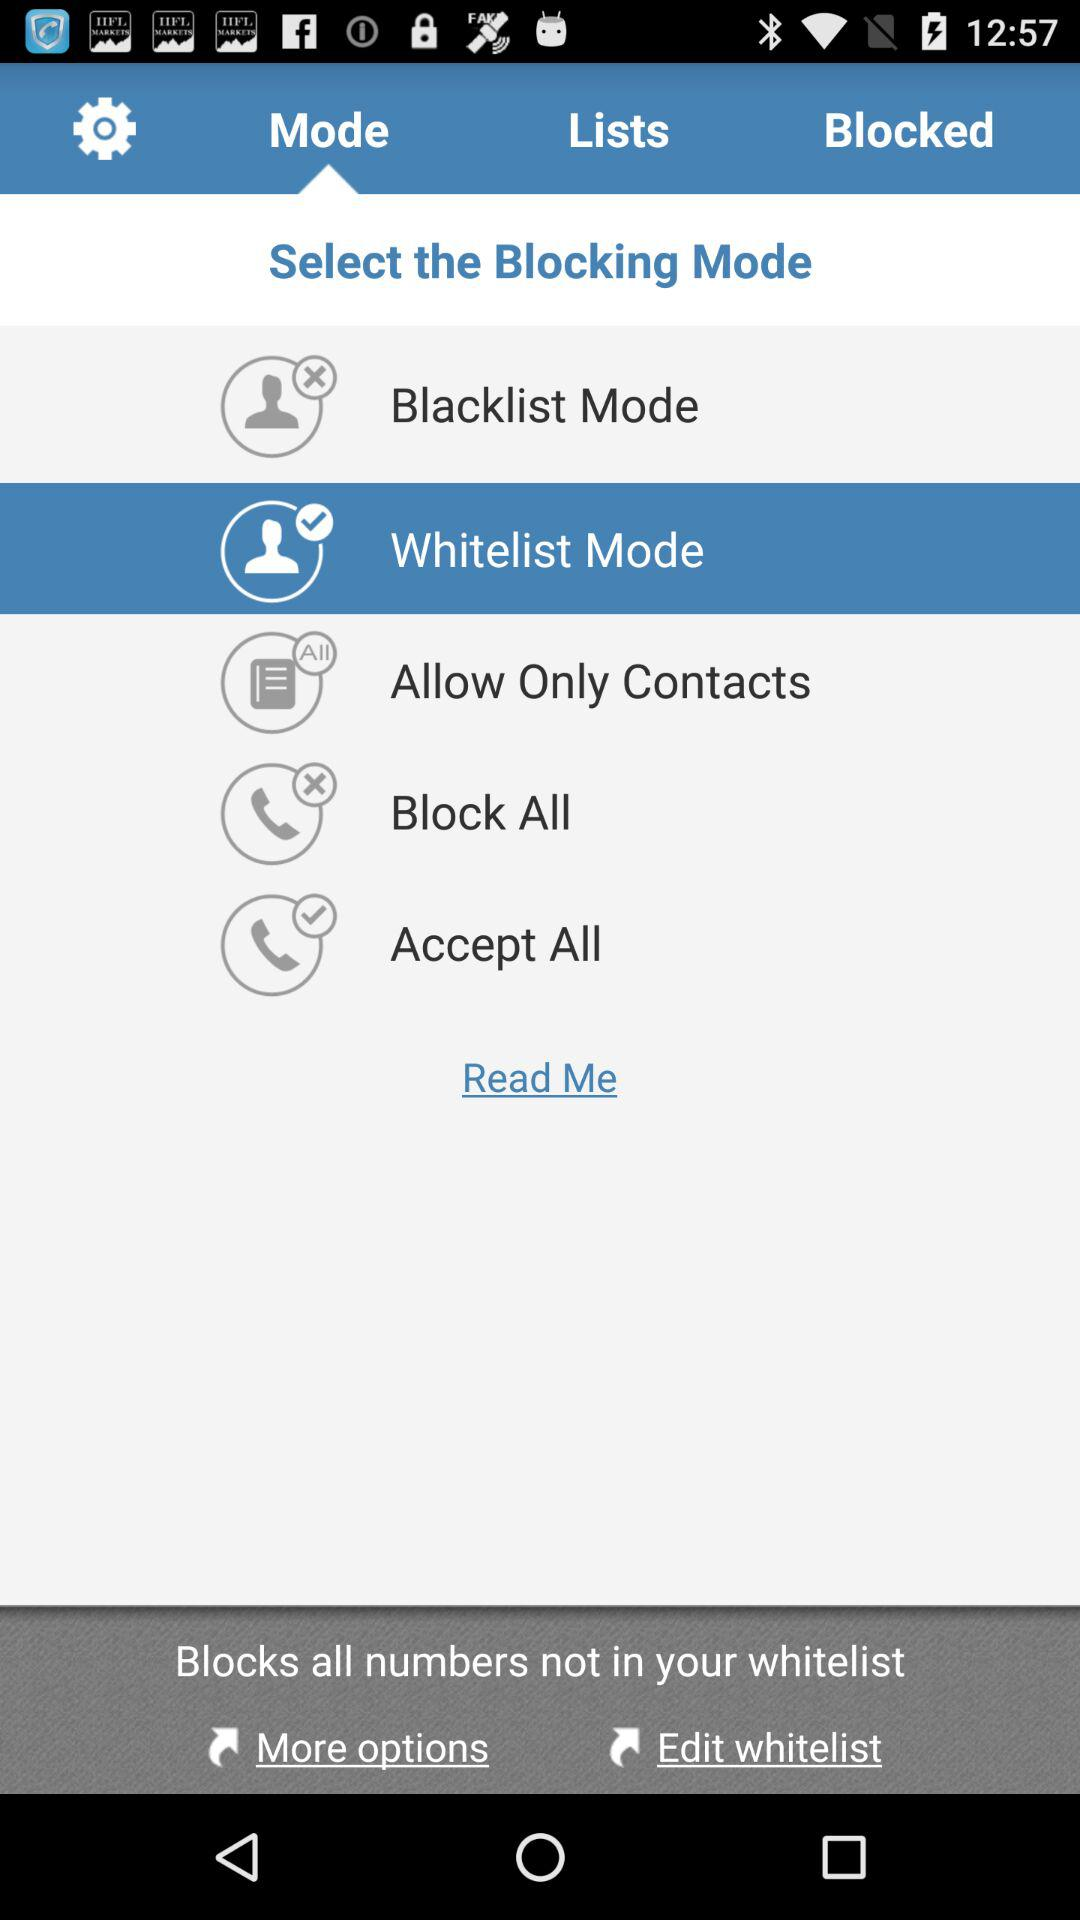What is the selected blocking mode? The selected blocking mode is "Whitelist Mode". 